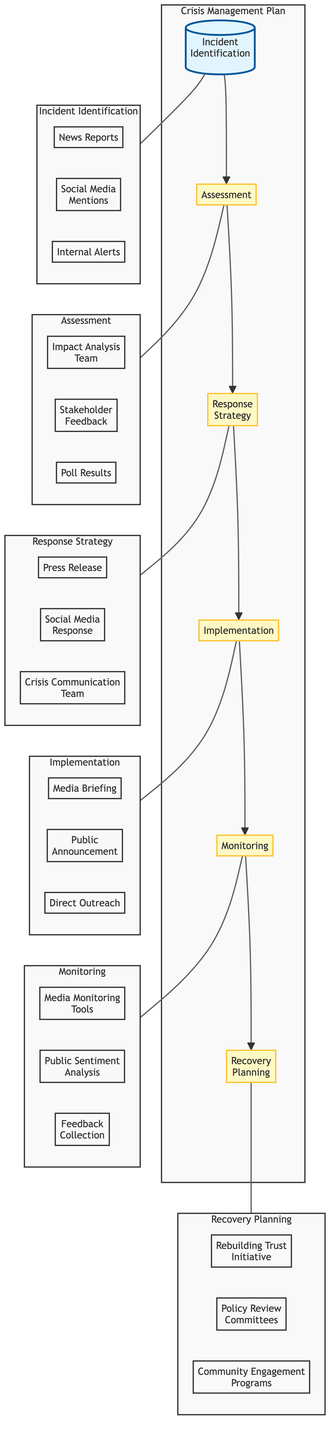What is the first step in the Crisis Management Plan? The first step in the Crisis Management Plan is Incident Identification, as indicated by its position as the starting node in the flow chart.
Answer: Incident Identification How many main steps are outlined in the Crisis Management Plan? The flow chart outlines six main steps: Incident Identification, Assessment, Response Strategy, Implementation, Monitoring, and Recovery Planning. By counting the nodes in the flow, we find that there are six distinct steps.
Answer: Six Which entities are involved in the Response Strategy? The entities involved in the Response Strategy, as listed in its details, are Press Release, Social Media Response, and Crisis Communication Team.
Answer: Press Release, Social Media Response, Crisis Communication Team What follows after the Implementation step? After the Implementation step, the next step in the flow is Monitoring, following the established order of processes in the diagram.
Answer: Monitoring Which sub-processes are associated with the Assessment step? The sub-processes associated with the Assessment step include Impact Analysis Team, Stakeholder Feedback, and Poll Results, as shown in the sub-graph detailing the Assessment.
Answer: Impact Analysis Team, Stakeholder Feedback, Poll Results What is the final goal of the Crisis Management Plan? The final goal of the Crisis Management Plan, as represented in the last node of the flow chart, is Recovery Planning, indicating a return to normalcy and long-term strategies.
Answer: Recovery Planning How does the incident identification relate to the monitoring step? Incident Identification is the first step that leads to Assessment, followed sequentially through Response Strategy, Implementation, and then to Monitoring, showing a direct relationship through the flow of the process.
Answer: Sequential relationship What kind of tools are utilized during the Monitoring phase? The tools utilized during the Monitoring phase, as specified in the relevant sub-processes, include Media Monitoring Tools, Public Sentiment Analysis, and Feedback Collection.
Answer: Media Monitoring Tools, Public Sentiment Analysis, Feedback Collection Which strategy is part of the Recovery Planning process? The strategies that fall under Recovery Planning include Rebuilding Trust Initiative, Policy Review Committees, and Community Engagement Programs, as detailed in the flow chart's last segment.
Answer: Rebuilding Trust Initiative, Policy Review Committees, Community Engagement Programs 